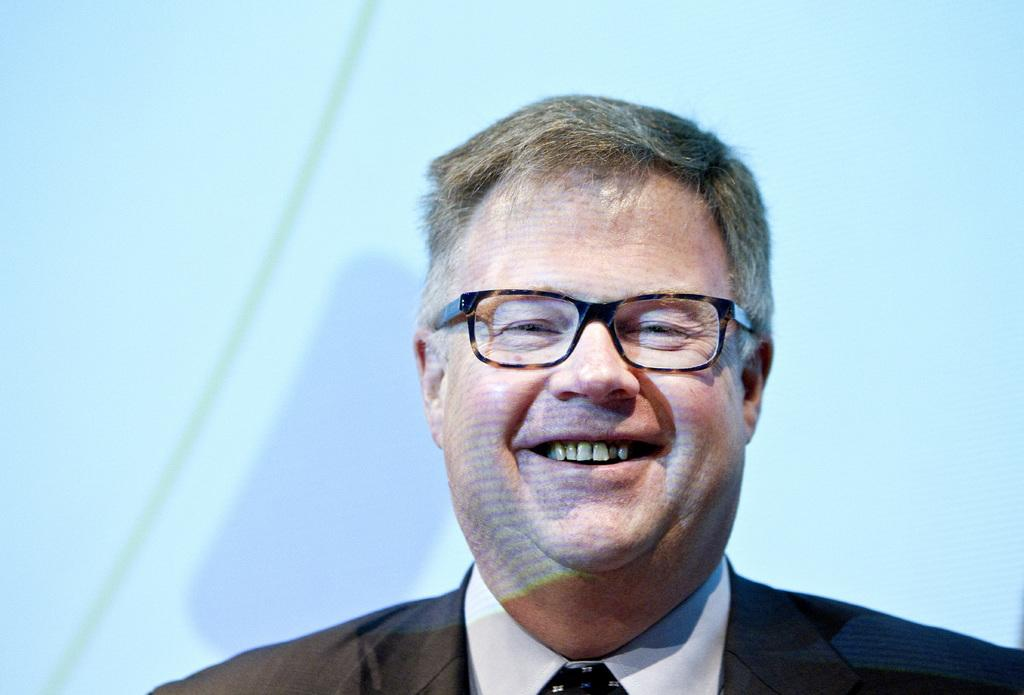What is the main subject of the image? There is a person in the image. What is the person's facial expression? The person is smiling. What type of clothing is the person wearing? The person is wearing a black suit. Are there any accessories visible on the person? Yes, the person is wearing spectacles. What type of basin is the person using to cook in the image? There is no basin or cooking activity present in the image. Can you provide the list of ingredients the person is using to prepare a dish in the image? There is no cooking or list of ingredients visible in the image. 